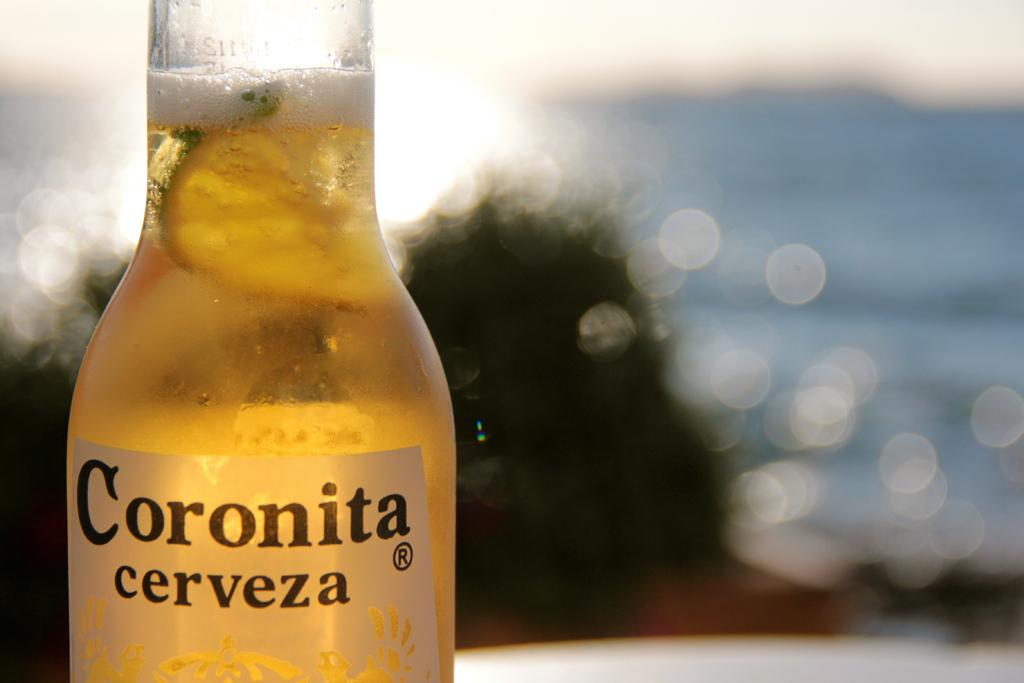Provide a one-sentence caption for the provided image. A bottle Coronita is in the foreground of a body of water. 